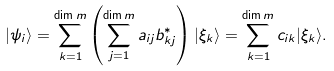Convert formula to latex. <formula><loc_0><loc_0><loc_500><loc_500>| \psi _ { i } \rangle = \sum _ { k = 1 } ^ { \dim m } \left ( \sum _ { j = 1 } ^ { \dim m } a _ { i j } b ^ { * } _ { k j } \right ) | \xi _ { k } \rangle = \sum _ { k = 1 } ^ { \dim m } c _ { i k } | \xi _ { k } \rangle .</formula> 